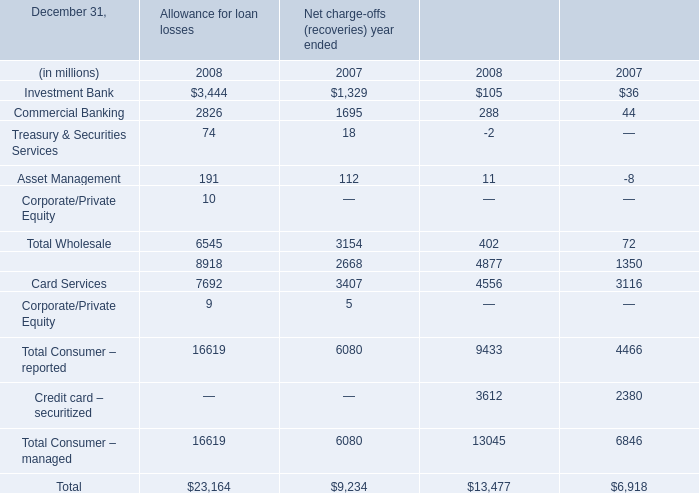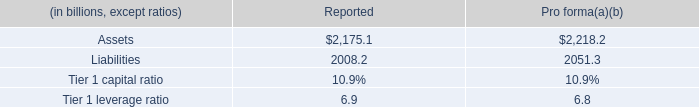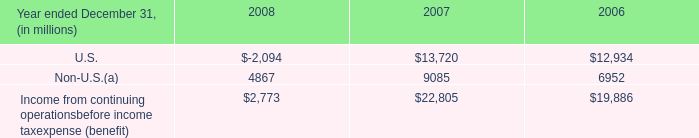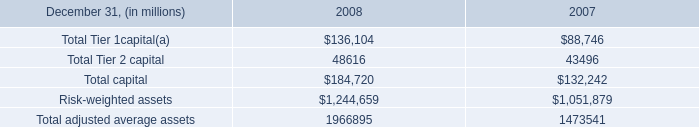by how many basis points would the tier 1 capital ratio improve if the firm were to consolidate the assets and liabilities of the conduits at fair value? 
Computations: ((10.9 - 10.8) * 100)
Answer: 10.0. 